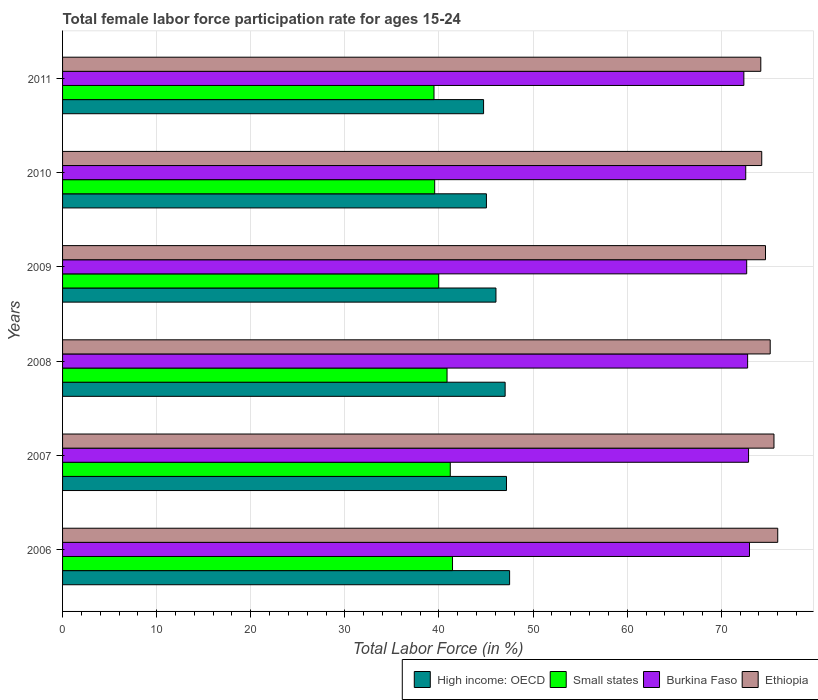How many different coloured bars are there?
Keep it short and to the point. 4. How many groups of bars are there?
Provide a succinct answer. 6. Are the number of bars per tick equal to the number of legend labels?
Make the answer very short. Yes. Are the number of bars on each tick of the Y-axis equal?
Provide a short and direct response. Yes. How many bars are there on the 3rd tick from the top?
Offer a very short reply. 4. What is the female labor force participation rate in Small states in 2009?
Your response must be concise. 39.97. Across all years, what is the maximum female labor force participation rate in Ethiopia?
Ensure brevity in your answer.  76. Across all years, what is the minimum female labor force participation rate in High income: OECD?
Offer a terse response. 44.74. In which year was the female labor force participation rate in Ethiopia maximum?
Make the answer very short. 2006. What is the total female labor force participation rate in Ethiopia in the graph?
Offer a terse response. 450. What is the difference between the female labor force participation rate in Burkina Faso in 2007 and that in 2010?
Keep it short and to the point. 0.3. What is the difference between the female labor force participation rate in High income: OECD in 2006 and the female labor force participation rate in Small states in 2008?
Give a very brief answer. 6.65. What is the average female labor force participation rate in Small states per year?
Keep it short and to the point. 40.41. In the year 2008, what is the difference between the female labor force participation rate in High income: OECD and female labor force participation rate in Small states?
Make the answer very short. 6.17. In how many years, is the female labor force participation rate in Burkina Faso greater than 18 %?
Provide a succinct answer. 6. What is the ratio of the female labor force participation rate in Small states in 2008 to that in 2011?
Your answer should be compact. 1.04. Is the female labor force participation rate in High income: OECD in 2007 less than that in 2010?
Keep it short and to the point. No. What is the difference between the highest and the second highest female labor force participation rate in High income: OECD?
Make the answer very short. 0.33. What is the difference between the highest and the lowest female labor force participation rate in Burkina Faso?
Give a very brief answer. 0.6. In how many years, is the female labor force participation rate in Small states greater than the average female labor force participation rate in Small states taken over all years?
Provide a short and direct response. 3. What does the 1st bar from the top in 2008 represents?
Give a very brief answer. Ethiopia. What does the 2nd bar from the bottom in 2007 represents?
Give a very brief answer. Small states. How many years are there in the graph?
Offer a terse response. 6. What is the difference between two consecutive major ticks on the X-axis?
Your answer should be very brief. 10. Are the values on the major ticks of X-axis written in scientific E-notation?
Your answer should be very brief. No. Does the graph contain any zero values?
Offer a very short reply. No. Does the graph contain grids?
Provide a short and direct response. Yes. Where does the legend appear in the graph?
Offer a very short reply. Bottom right. How many legend labels are there?
Your answer should be compact. 4. How are the legend labels stacked?
Provide a succinct answer. Horizontal. What is the title of the graph?
Your response must be concise. Total female labor force participation rate for ages 15-24. Does "Comoros" appear as one of the legend labels in the graph?
Your answer should be compact. No. What is the label or title of the X-axis?
Offer a terse response. Total Labor Force (in %). What is the Total Labor Force (in %) in High income: OECD in 2006?
Provide a succinct answer. 47.51. What is the Total Labor Force (in %) of Small states in 2006?
Your answer should be compact. 41.44. What is the Total Labor Force (in %) in Burkina Faso in 2006?
Keep it short and to the point. 73. What is the Total Labor Force (in %) in High income: OECD in 2007?
Make the answer very short. 47.17. What is the Total Labor Force (in %) in Small states in 2007?
Keep it short and to the point. 41.2. What is the Total Labor Force (in %) of Burkina Faso in 2007?
Ensure brevity in your answer.  72.9. What is the Total Labor Force (in %) in Ethiopia in 2007?
Your response must be concise. 75.6. What is the Total Labor Force (in %) of High income: OECD in 2008?
Ensure brevity in your answer.  47.03. What is the Total Labor Force (in %) of Small states in 2008?
Offer a very short reply. 40.86. What is the Total Labor Force (in %) of Burkina Faso in 2008?
Ensure brevity in your answer.  72.8. What is the Total Labor Force (in %) in Ethiopia in 2008?
Provide a short and direct response. 75.2. What is the Total Labor Force (in %) in High income: OECD in 2009?
Your answer should be compact. 46.06. What is the Total Labor Force (in %) of Small states in 2009?
Your response must be concise. 39.97. What is the Total Labor Force (in %) of Burkina Faso in 2009?
Offer a terse response. 72.7. What is the Total Labor Force (in %) of Ethiopia in 2009?
Keep it short and to the point. 74.7. What is the Total Labor Force (in %) in High income: OECD in 2010?
Provide a succinct answer. 45.04. What is the Total Labor Force (in %) of Small states in 2010?
Offer a terse response. 39.54. What is the Total Labor Force (in %) of Burkina Faso in 2010?
Offer a terse response. 72.6. What is the Total Labor Force (in %) of Ethiopia in 2010?
Ensure brevity in your answer.  74.3. What is the Total Labor Force (in %) in High income: OECD in 2011?
Your answer should be compact. 44.74. What is the Total Labor Force (in %) of Small states in 2011?
Ensure brevity in your answer.  39.47. What is the Total Labor Force (in %) in Burkina Faso in 2011?
Your answer should be very brief. 72.4. What is the Total Labor Force (in %) of Ethiopia in 2011?
Make the answer very short. 74.2. Across all years, what is the maximum Total Labor Force (in %) in High income: OECD?
Provide a short and direct response. 47.51. Across all years, what is the maximum Total Labor Force (in %) of Small states?
Your response must be concise. 41.44. Across all years, what is the minimum Total Labor Force (in %) in High income: OECD?
Keep it short and to the point. 44.74. Across all years, what is the minimum Total Labor Force (in %) in Small states?
Your answer should be very brief. 39.47. Across all years, what is the minimum Total Labor Force (in %) of Burkina Faso?
Make the answer very short. 72.4. Across all years, what is the minimum Total Labor Force (in %) of Ethiopia?
Ensure brevity in your answer.  74.2. What is the total Total Labor Force (in %) of High income: OECD in the graph?
Give a very brief answer. 277.55. What is the total Total Labor Force (in %) of Small states in the graph?
Provide a short and direct response. 242.49. What is the total Total Labor Force (in %) of Burkina Faso in the graph?
Provide a succinct answer. 436.4. What is the total Total Labor Force (in %) of Ethiopia in the graph?
Make the answer very short. 450. What is the difference between the Total Labor Force (in %) of High income: OECD in 2006 and that in 2007?
Provide a succinct answer. 0.33. What is the difference between the Total Labor Force (in %) of Small states in 2006 and that in 2007?
Your response must be concise. 0.24. What is the difference between the Total Labor Force (in %) in Burkina Faso in 2006 and that in 2007?
Offer a very short reply. 0.1. What is the difference between the Total Labor Force (in %) of High income: OECD in 2006 and that in 2008?
Your response must be concise. 0.47. What is the difference between the Total Labor Force (in %) of Small states in 2006 and that in 2008?
Your answer should be compact. 0.58. What is the difference between the Total Labor Force (in %) of High income: OECD in 2006 and that in 2009?
Give a very brief answer. 1.45. What is the difference between the Total Labor Force (in %) in Small states in 2006 and that in 2009?
Keep it short and to the point. 1.47. What is the difference between the Total Labor Force (in %) of Burkina Faso in 2006 and that in 2009?
Ensure brevity in your answer.  0.3. What is the difference between the Total Labor Force (in %) of Ethiopia in 2006 and that in 2009?
Offer a very short reply. 1.3. What is the difference between the Total Labor Force (in %) in High income: OECD in 2006 and that in 2010?
Your response must be concise. 2.46. What is the difference between the Total Labor Force (in %) in Small states in 2006 and that in 2010?
Offer a very short reply. 1.9. What is the difference between the Total Labor Force (in %) in Ethiopia in 2006 and that in 2010?
Your response must be concise. 1.7. What is the difference between the Total Labor Force (in %) in High income: OECD in 2006 and that in 2011?
Provide a succinct answer. 2.77. What is the difference between the Total Labor Force (in %) of Small states in 2006 and that in 2011?
Provide a succinct answer. 1.97. What is the difference between the Total Labor Force (in %) in High income: OECD in 2007 and that in 2008?
Provide a short and direct response. 0.14. What is the difference between the Total Labor Force (in %) of Small states in 2007 and that in 2008?
Provide a short and direct response. 0.34. What is the difference between the Total Labor Force (in %) in Burkina Faso in 2007 and that in 2008?
Provide a short and direct response. 0.1. What is the difference between the Total Labor Force (in %) of Ethiopia in 2007 and that in 2008?
Your response must be concise. 0.4. What is the difference between the Total Labor Force (in %) in High income: OECD in 2007 and that in 2009?
Offer a terse response. 1.12. What is the difference between the Total Labor Force (in %) in Small states in 2007 and that in 2009?
Make the answer very short. 1.23. What is the difference between the Total Labor Force (in %) in Ethiopia in 2007 and that in 2009?
Ensure brevity in your answer.  0.9. What is the difference between the Total Labor Force (in %) in High income: OECD in 2007 and that in 2010?
Your response must be concise. 2.13. What is the difference between the Total Labor Force (in %) of Small states in 2007 and that in 2010?
Your answer should be very brief. 1.66. What is the difference between the Total Labor Force (in %) in Ethiopia in 2007 and that in 2010?
Your answer should be very brief. 1.3. What is the difference between the Total Labor Force (in %) of High income: OECD in 2007 and that in 2011?
Give a very brief answer. 2.43. What is the difference between the Total Labor Force (in %) in Small states in 2007 and that in 2011?
Your answer should be very brief. 1.73. What is the difference between the Total Labor Force (in %) in Burkina Faso in 2007 and that in 2011?
Provide a short and direct response. 0.5. What is the difference between the Total Labor Force (in %) in High income: OECD in 2008 and that in 2009?
Offer a very short reply. 0.98. What is the difference between the Total Labor Force (in %) in Small states in 2008 and that in 2009?
Your answer should be very brief. 0.88. What is the difference between the Total Labor Force (in %) of Burkina Faso in 2008 and that in 2009?
Your answer should be very brief. 0.1. What is the difference between the Total Labor Force (in %) of Ethiopia in 2008 and that in 2009?
Provide a succinct answer. 0.5. What is the difference between the Total Labor Force (in %) of High income: OECD in 2008 and that in 2010?
Your answer should be very brief. 1.99. What is the difference between the Total Labor Force (in %) of Small states in 2008 and that in 2010?
Keep it short and to the point. 1.31. What is the difference between the Total Labor Force (in %) in High income: OECD in 2008 and that in 2011?
Make the answer very short. 2.29. What is the difference between the Total Labor Force (in %) in Small states in 2008 and that in 2011?
Ensure brevity in your answer.  1.39. What is the difference between the Total Labor Force (in %) of High income: OECD in 2009 and that in 2010?
Provide a succinct answer. 1.01. What is the difference between the Total Labor Force (in %) of Small states in 2009 and that in 2010?
Your response must be concise. 0.43. What is the difference between the Total Labor Force (in %) of High income: OECD in 2009 and that in 2011?
Offer a very short reply. 1.32. What is the difference between the Total Labor Force (in %) of Small states in 2009 and that in 2011?
Your answer should be compact. 0.5. What is the difference between the Total Labor Force (in %) in High income: OECD in 2010 and that in 2011?
Provide a short and direct response. 0.3. What is the difference between the Total Labor Force (in %) of Small states in 2010 and that in 2011?
Keep it short and to the point. 0.07. What is the difference between the Total Labor Force (in %) of High income: OECD in 2006 and the Total Labor Force (in %) of Small states in 2007?
Offer a terse response. 6.31. What is the difference between the Total Labor Force (in %) in High income: OECD in 2006 and the Total Labor Force (in %) in Burkina Faso in 2007?
Your answer should be compact. -25.39. What is the difference between the Total Labor Force (in %) in High income: OECD in 2006 and the Total Labor Force (in %) in Ethiopia in 2007?
Provide a succinct answer. -28.09. What is the difference between the Total Labor Force (in %) of Small states in 2006 and the Total Labor Force (in %) of Burkina Faso in 2007?
Your answer should be very brief. -31.46. What is the difference between the Total Labor Force (in %) of Small states in 2006 and the Total Labor Force (in %) of Ethiopia in 2007?
Give a very brief answer. -34.16. What is the difference between the Total Labor Force (in %) in Burkina Faso in 2006 and the Total Labor Force (in %) in Ethiopia in 2007?
Keep it short and to the point. -2.6. What is the difference between the Total Labor Force (in %) in High income: OECD in 2006 and the Total Labor Force (in %) in Small states in 2008?
Provide a succinct answer. 6.65. What is the difference between the Total Labor Force (in %) of High income: OECD in 2006 and the Total Labor Force (in %) of Burkina Faso in 2008?
Offer a terse response. -25.29. What is the difference between the Total Labor Force (in %) of High income: OECD in 2006 and the Total Labor Force (in %) of Ethiopia in 2008?
Keep it short and to the point. -27.69. What is the difference between the Total Labor Force (in %) in Small states in 2006 and the Total Labor Force (in %) in Burkina Faso in 2008?
Your answer should be very brief. -31.36. What is the difference between the Total Labor Force (in %) in Small states in 2006 and the Total Labor Force (in %) in Ethiopia in 2008?
Your answer should be compact. -33.76. What is the difference between the Total Labor Force (in %) in High income: OECD in 2006 and the Total Labor Force (in %) in Small states in 2009?
Provide a succinct answer. 7.53. What is the difference between the Total Labor Force (in %) of High income: OECD in 2006 and the Total Labor Force (in %) of Burkina Faso in 2009?
Provide a short and direct response. -25.19. What is the difference between the Total Labor Force (in %) of High income: OECD in 2006 and the Total Labor Force (in %) of Ethiopia in 2009?
Make the answer very short. -27.19. What is the difference between the Total Labor Force (in %) in Small states in 2006 and the Total Labor Force (in %) in Burkina Faso in 2009?
Provide a short and direct response. -31.26. What is the difference between the Total Labor Force (in %) of Small states in 2006 and the Total Labor Force (in %) of Ethiopia in 2009?
Offer a very short reply. -33.26. What is the difference between the Total Labor Force (in %) in Burkina Faso in 2006 and the Total Labor Force (in %) in Ethiopia in 2009?
Provide a short and direct response. -1.7. What is the difference between the Total Labor Force (in %) in High income: OECD in 2006 and the Total Labor Force (in %) in Small states in 2010?
Your answer should be very brief. 7.96. What is the difference between the Total Labor Force (in %) in High income: OECD in 2006 and the Total Labor Force (in %) in Burkina Faso in 2010?
Your answer should be compact. -25.09. What is the difference between the Total Labor Force (in %) in High income: OECD in 2006 and the Total Labor Force (in %) in Ethiopia in 2010?
Provide a short and direct response. -26.79. What is the difference between the Total Labor Force (in %) in Small states in 2006 and the Total Labor Force (in %) in Burkina Faso in 2010?
Offer a very short reply. -31.16. What is the difference between the Total Labor Force (in %) of Small states in 2006 and the Total Labor Force (in %) of Ethiopia in 2010?
Your answer should be compact. -32.86. What is the difference between the Total Labor Force (in %) in Burkina Faso in 2006 and the Total Labor Force (in %) in Ethiopia in 2010?
Your answer should be very brief. -1.3. What is the difference between the Total Labor Force (in %) in High income: OECD in 2006 and the Total Labor Force (in %) in Small states in 2011?
Offer a terse response. 8.03. What is the difference between the Total Labor Force (in %) in High income: OECD in 2006 and the Total Labor Force (in %) in Burkina Faso in 2011?
Offer a very short reply. -24.89. What is the difference between the Total Labor Force (in %) in High income: OECD in 2006 and the Total Labor Force (in %) in Ethiopia in 2011?
Make the answer very short. -26.69. What is the difference between the Total Labor Force (in %) of Small states in 2006 and the Total Labor Force (in %) of Burkina Faso in 2011?
Your answer should be compact. -30.96. What is the difference between the Total Labor Force (in %) in Small states in 2006 and the Total Labor Force (in %) in Ethiopia in 2011?
Your response must be concise. -32.76. What is the difference between the Total Labor Force (in %) of High income: OECD in 2007 and the Total Labor Force (in %) of Small states in 2008?
Make the answer very short. 6.32. What is the difference between the Total Labor Force (in %) of High income: OECD in 2007 and the Total Labor Force (in %) of Burkina Faso in 2008?
Provide a succinct answer. -25.63. What is the difference between the Total Labor Force (in %) of High income: OECD in 2007 and the Total Labor Force (in %) of Ethiopia in 2008?
Your answer should be very brief. -28.03. What is the difference between the Total Labor Force (in %) in Small states in 2007 and the Total Labor Force (in %) in Burkina Faso in 2008?
Provide a succinct answer. -31.6. What is the difference between the Total Labor Force (in %) in Small states in 2007 and the Total Labor Force (in %) in Ethiopia in 2008?
Ensure brevity in your answer.  -34. What is the difference between the Total Labor Force (in %) in Burkina Faso in 2007 and the Total Labor Force (in %) in Ethiopia in 2008?
Keep it short and to the point. -2.3. What is the difference between the Total Labor Force (in %) of High income: OECD in 2007 and the Total Labor Force (in %) of Small states in 2009?
Your answer should be very brief. 7.2. What is the difference between the Total Labor Force (in %) of High income: OECD in 2007 and the Total Labor Force (in %) of Burkina Faso in 2009?
Make the answer very short. -25.53. What is the difference between the Total Labor Force (in %) in High income: OECD in 2007 and the Total Labor Force (in %) in Ethiopia in 2009?
Make the answer very short. -27.53. What is the difference between the Total Labor Force (in %) of Small states in 2007 and the Total Labor Force (in %) of Burkina Faso in 2009?
Offer a terse response. -31.5. What is the difference between the Total Labor Force (in %) in Small states in 2007 and the Total Labor Force (in %) in Ethiopia in 2009?
Provide a short and direct response. -33.5. What is the difference between the Total Labor Force (in %) in Burkina Faso in 2007 and the Total Labor Force (in %) in Ethiopia in 2009?
Ensure brevity in your answer.  -1.8. What is the difference between the Total Labor Force (in %) of High income: OECD in 2007 and the Total Labor Force (in %) of Small states in 2010?
Make the answer very short. 7.63. What is the difference between the Total Labor Force (in %) of High income: OECD in 2007 and the Total Labor Force (in %) of Burkina Faso in 2010?
Your answer should be very brief. -25.43. What is the difference between the Total Labor Force (in %) in High income: OECD in 2007 and the Total Labor Force (in %) in Ethiopia in 2010?
Offer a terse response. -27.13. What is the difference between the Total Labor Force (in %) of Small states in 2007 and the Total Labor Force (in %) of Burkina Faso in 2010?
Ensure brevity in your answer.  -31.4. What is the difference between the Total Labor Force (in %) of Small states in 2007 and the Total Labor Force (in %) of Ethiopia in 2010?
Make the answer very short. -33.1. What is the difference between the Total Labor Force (in %) in High income: OECD in 2007 and the Total Labor Force (in %) in Small states in 2011?
Offer a terse response. 7.7. What is the difference between the Total Labor Force (in %) of High income: OECD in 2007 and the Total Labor Force (in %) of Burkina Faso in 2011?
Provide a succinct answer. -25.23. What is the difference between the Total Labor Force (in %) of High income: OECD in 2007 and the Total Labor Force (in %) of Ethiopia in 2011?
Your answer should be compact. -27.03. What is the difference between the Total Labor Force (in %) of Small states in 2007 and the Total Labor Force (in %) of Burkina Faso in 2011?
Ensure brevity in your answer.  -31.2. What is the difference between the Total Labor Force (in %) in Small states in 2007 and the Total Labor Force (in %) in Ethiopia in 2011?
Provide a short and direct response. -33. What is the difference between the Total Labor Force (in %) in Burkina Faso in 2007 and the Total Labor Force (in %) in Ethiopia in 2011?
Make the answer very short. -1.3. What is the difference between the Total Labor Force (in %) in High income: OECD in 2008 and the Total Labor Force (in %) in Small states in 2009?
Your response must be concise. 7.06. What is the difference between the Total Labor Force (in %) of High income: OECD in 2008 and the Total Labor Force (in %) of Burkina Faso in 2009?
Give a very brief answer. -25.67. What is the difference between the Total Labor Force (in %) in High income: OECD in 2008 and the Total Labor Force (in %) in Ethiopia in 2009?
Offer a terse response. -27.67. What is the difference between the Total Labor Force (in %) of Small states in 2008 and the Total Labor Force (in %) of Burkina Faso in 2009?
Your response must be concise. -31.84. What is the difference between the Total Labor Force (in %) of Small states in 2008 and the Total Labor Force (in %) of Ethiopia in 2009?
Your answer should be very brief. -33.84. What is the difference between the Total Labor Force (in %) of High income: OECD in 2008 and the Total Labor Force (in %) of Small states in 2010?
Keep it short and to the point. 7.49. What is the difference between the Total Labor Force (in %) of High income: OECD in 2008 and the Total Labor Force (in %) of Burkina Faso in 2010?
Give a very brief answer. -25.57. What is the difference between the Total Labor Force (in %) of High income: OECD in 2008 and the Total Labor Force (in %) of Ethiopia in 2010?
Offer a very short reply. -27.27. What is the difference between the Total Labor Force (in %) in Small states in 2008 and the Total Labor Force (in %) in Burkina Faso in 2010?
Provide a succinct answer. -31.74. What is the difference between the Total Labor Force (in %) in Small states in 2008 and the Total Labor Force (in %) in Ethiopia in 2010?
Your answer should be very brief. -33.44. What is the difference between the Total Labor Force (in %) in High income: OECD in 2008 and the Total Labor Force (in %) in Small states in 2011?
Your response must be concise. 7.56. What is the difference between the Total Labor Force (in %) in High income: OECD in 2008 and the Total Labor Force (in %) in Burkina Faso in 2011?
Keep it short and to the point. -25.37. What is the difference between the Total Labor Force (in %) in High income: OECD in 2008 and the Total Labor Force (in %) in Ethiopia in 2011?
Your answer should be very brief. -27.17. What is the difference between the Total Labor Force (in %) of Small states in 2008 and the Total Labor Force (in %) of Burkina Faso in 2011?
Provide a short and direct response. -31.54. What is the difference between the Total Labor Force (in %) in Small states in 2008 and the Total Labor Force (in %) in Ethiopia in 2011?
Provide a succinct answer. -33.34. What is the difference between the Total Labor Force (in %) of High income: OECD in 2009 and the Total Labor Force (in %) of Small states in 2010?
Provide a succinct answer. 6.51. What is the difference between the Total Labor Force (in %) in High income: OECD in 2009 and the Total Labor Force (in %) in Burkina Faso in 2010?
Provide a succinct answer. -26.54. What is the difference between the Total Labor Force (in %) in High income: OECD in 2009 and the Total Labor Force (in %) in Ethiopia in 2010?
Provide a short and direct response. -28.24. What is the difference between the Total Labor Force (in %) of Small states in 2009 and the Total Labor Force (in %) of Burkina Faso in 2010?
Offer a terse response. -32.63. What is the difference between the Total Labor Force (in %) of Small states in 2009 and the Total Labor Force (in %) of Ethiopia in 2010?
Your answer should be compact. -34.33. What is the difference between the Total Labor Force (in %) of High income: OECD in 2009 and the Total Labor Force (in %) of Small states in 2011?
Your response must be concise. 6.58. What is the difference between the Total Labor Force (in %) in High income: OECD in 2009 and the Total Labor Force (in %) in Burkina Faso in 2011?
Offer a very short reply. -26.34. What is the difference between the Total Labor Force (in %) in High income: OECD in 2009 and the Total Labor Force (in %) in Ethiopia in 2011?
Your answer should be very brief. -28.14. What is the difference between the Total Labor Force (in %) in Small states in 2009 and the Total Labor Force (in %) in Burkina Faso in 2011?
Your answer should be very brief. -32.43. What is the difference between the Total Labor Force (in %) of Small states in 2009 and the Total Labor Force (in %) of Ethiopia in 2011?
Ensure brevity in your answer.  -34.23. What is the difference between the Total Labor Force (in %) of Burkina Faso in 2009 and the Total Labor Force (in %) of Ethiopia in 2011?
Offer a very short reply. -1.5. What is the difference between the Total Labor Force (in %) of High income: OECD in 2010 and the Total Labor Force (in %) of Small states in 2011?
Your answer should be very brief. 5.57. What is the difference between the Total Labor Force (in %) of High income: OECD in 2010 and the Total Labor Force (in %) of Burkina Faso in 2011?
Provide a succinct answer. -27.36. What is the difference between the Total Labor Force (in %) of High income: OECD in 2010 and the Total Labor Force (in %) of Ethiopia in 2011?
Keep it short and to the point. -29.16. What is the difference between the Total Labor Force (in %) of Small states in 2010 and the Total Labor Force (in %) of Burkina Faso in 2011?
Provide a short and direct response. -32.86. What is the difference between the Total Labor Force (in %) in Small states in 2010 and the Total Labor Force (in %) in Ethiopia in 2011?
Give a very brief answer. -34.66. What is the difference between the Total Labor Force (in %) in Burkina Faso in 2010 and the Total Labor Force (in %) in Ethiopia in 2011?
Offer a terse response. -1.6. What is the average Total Labor Force (in %) in High income: OECD per year?
Give a very brief answer. 46.26. What is the average Total Labor Force (in %) of Small states per year?
Keep it short and to the point. 40.41. What is the average Total Labor Force (in %) of Burkina Faso per year?
Your response must be concise. 72.73. In the year 2006, what is the difference between the Total Labor Force (in %) of High income: OECD and Total Labor Force (in %) of Small states?
Make the answer very short. 6.07. In the year 2006, what is the difference between the Total Labor Force (in %) in High income: OECD and Total Labor Force (in %) in Burkina Faso?
Give a very brief answer. -25.49. In the year 2006, what is the difference between the Total Labor Force (in %) of High income: OECD and Total Labor Force (in %) of Ethiopia?
Offer a very short reply. -28.49. In the year 2006, what is the difference between the Total Labor Force (in %) of Small states and Total Labor Force (in %) of Burkina Faso?
Make the answer very short. -31.56. In the year 2006, what is the difference between the Total Labor Force (in %) of Small states and Total Labor Force (in %) of Ethiopia?
Provide a succinct answer. -34.56. In the year 2006, what is the difference between the Total Labor Force (in %) in Burkina Faso and Total Labor Force (in %) in Ethiopia?
Provide a short and direct response. -3. In the year 2007, what is the difference between the Total Labor Force (in %) of High income: OECD and Total Labor Force (in %) of Small states?
Give a very brief answer. 5.97. In the year 2007, what is the difference between the Total Labor Force (in %) in High income: OECD and Total Labor Force (in %) in Burkina Faso?
Give a very brief answer. -25.73. In the year 2007, what is the difference between the Total Labor Force (in %) of High income: OECD and Total Labor Force (in %) of Ethiopia?
Ensure brevity in your answer.  -28.43. In the year 2007, what is the difference between the Total Labor Force (in %) in Small states and Total Labor Force (in %) in Burkina Faso?
Your answer should be very brief. -31.7. In the year 2007, what is the difference between the Total Labor Force (in %) of Small states and Total Labor Force (in %) of Ethiopia?
Ensure brevity in your answer.  -34.4. In the year 2008, what is the difference between the Total Labor Force (in %) in High income: OECD and Total Labor Force (in %) in Small states?
Give a very brief answer. 6.17. In the year 2008, what is the difference between the Total Labor Force (in %) of High income: OECD and Total Labor Force (in %) of Burkina Faso?
Keep it short and to the point. -25.77. In the year 2008, what is the difference between the Total Labor Force (in %) of High income: OECD and Total Labor Force (in %) of Ethiopia?
Give a very brief answer. -28.17. In the year 2008, what is the difference between the Total Labor Force (in %) in Small states and Total Labor Force (in %) in Burkina Faso?
Keep it short and to the point. -31.94. In the year 2008, what is the difference between the Total Labor Force (in %) in Small states and Total Labor Force (in %) in Ethiopia?
Provide a short and direct response. -34.34. In the year 2009, what is the difference between the Total Labor Force (in %) in High income: OECD and Total Labor Force (in %) in Small states?
Make the answer very short. 6.08. In the year 2009, what is the difference between the Total Labor Force (in %) of High income: OECD and Total Labor Force (in %) of Burkina Faso?
Keep it short and to the point. -26.64. In the year 2009, what is the difference between the Total Labor Force (in %) of High income: OECD and Total Labor Force (in %) of Ethiopia?
Give a very brief answer. -28.64. In the year 2009, what is the difference between the Total Labor Force (in %) in Small states and Total Labor Force (in %) in Burkina Faso?
Give a very brief answer. -32.73. In the year 2009, what is the difference between the Total Labor Force (in %) of Small states and Total Labor Force (in %) of Ethiopia?
Provide a short and direct response. -34.73. In the year 2009, what is the difference between the Total Labor Force (in %) in Burkina Faso and Total Labor Force (in %) in Ethiopia?
Keep it short and to the point. -2. In the year 2010, what is the difference between the Total Labor Force (in %) in High income: OECD and Total Labor Force (in %) in Small states?
Give a very brief answer. 5.5. In the year 2010, what is the difference between the Total Labor Force (in %) of High income: OECD and Total Labor Force (in %) of Burkina Faso?
Your answer should be very brief. -27.56. In the year 2010, what is the difference between the Total Labor Force (in %) in High income: OECD and Total Labor Force (in %) in Ethiopia?
Offer a terse response. -29.26. In the year 2010, what is the difference between the Total Labor Force (in %) of Small states and Total Labor Force (in %) of Burkina Faso?
Your response must be concise. -33.06. In the year 2010, what is the difference between the Total Labor Force (in %) of Small states and Total Labor Force (in %) of Ethiopia?
Ensure brevity in your answer.  -34.76. In the year 2011, what is the difference between the Total Labor Force (in %) of High income: OECD and Total Labor Force (in %) of Small states?
Offer a terse response. 5.27. In the year 2011, what is the difference between the Total Labor Force (in %) in High income: OECD and Total Labor Force (in %) in Burkina Faso?
Your answer should be very brief. -27.66. In the year 2011, what is the difference between the Total Labor Force (in %) of High income: OECD and Total Labor Force (in %) of Ethiopia?
Keep it short and to the point. -29.46. In the year 2011, what is the difference between the Total Labor Force (in %) in Small states and Total Labor Force (in %) in Burkina Faso?
Offer a very short reply. -32.93. In the year 2011, what is the difference between the Total Labor Force (in %) of Small states and Total Labor Force (in %) of Ethiopia?
Give a very brief answer. -34.73. In the year 2011, what is the difference between the Total Labor Force (in %) of Burkina Faso and Total Labor Force (in %) of Ethiopia?
Keep it short and to the point. -1.8. What is the ratio of the Total Labor Force (in %) in Small states in 2006 to that in 2007?
Give a very brief answer. 1.01. What is the ratio of the Total Labor Force (in %) in Burkina Faso in 2006 to that in 2007?
Offer a terse response. 1. What is the ratio of the Total Labor Force (in %) of Small states in 2006 to that in 2008?
Your response must be concise. 1.01. What is the ratio of the Total Labor Force (in %) of Ethiopia in 2006 to that in 2008?
Offer a terse response. 1.01. What is the ratio of the Total Labor Force (in %) in High income: OECD in 2006 to that in 2009?
Provide a succinct answer. 1.03. What is the ratio of the Total Labor Force (in %) in Small states in 2006 to that in 2009?
Provide a short and direct response. 1.04. What is the ratio of the Total Labor Force (in %) in Ethiopia in 2006 to that in 2009?
Provide a short and direct response. 1.02. What is the ratio of the Total Labor Force (in %) of High income: OECD in 2006 to that in 2010?
Offer a terse response. 1.05. What is the ratio of the Total Labor Force (in %) in Small states in 2006 to that in 2010?
Your response must be concise. 1.05. What is the ratio of the Total Labor Force (in %) of Burkina Faso in 2006 to that in 2010?
Your answer should be very brief. 1.01. What is the ratio of the Total Labor Force (in %) of Ethiopia in 2006 to that in 2010?
Keep it short and to the point. 1.02. What is the ratio of the Total Labor Force (in %) in High income: OECD in 2006 to that in 2011?
Provide a short and direct response. 1.06. What is the ratio of the Total Labor Force (in %) in Small states in 2006 to that in 2011?
Make the answer very short. 1.05. What is the ratio of the Total Labor Force (in %) of Burkina Faso in 2006 to that in 2011?
Your answer should be very brief. 1.01. What is the ratio of the Total Labor Force (in %) of Ethiopia in 2006 to that in 2011?
Offer a very short reply. 1.02. What is the ratio of the Total Labor Force (in %) of Small states in 2007 to that in 2008?
Your answer should be compact. 1.01. What is the ratio of the Total Labor Force (in %) in Burkina Faso in 2007 to that in 2008?
Offer a very short reply. 1. What is the ratio of the Total Labor Force (in %) in Ethiopia in 2007 to that in 2008?
Offer a terse response. 1.01. What is the ratio of the Total Labor Force (in %) in High income: OECD in 2007 to that in 2009?
Offer a terse response. 1.02. What is the ratio of the Total Labor Force (in %) in Small states in 2007 to that in 2009?
Your response must be concise. 1.03. What is the ratio of the Total Labor Force (in %) in Burkina Faso in 2007 to that in 2009?
Provide a short and direct response. 1. What is the ratio of the Total Labor Force (in %) in Ethiopia in 2007 to that in 2009?
Your answer should be very brief. 1.01. What is the ratio of the Total Labor Force (in %) of High income: OECD in 2007 to that in 2010?
Keep it short and to the point. 1.05. What is the ratio of the Total Labor Force (in %) in Small states in 2007 to that in 2010?
Keep it short and to the point. 1.04. What is the ratio of the Total Labor Force (in %) in Burkina Faso in 2007 to that in 2010?
Ensure brevity in your answer.  1. What is the ratio of the Total Labor Force (in %) in Ethiopia in 2007 to that in 2010?
Provide a succinct answer. 1.02. What is the ratio of the Total Labor Force (in %) in High income: OECD in 2007 to that in 2011?
Offer a very short reply. 1.05. What is the ratio of the Total Labor Force (in %) of Small states in 2007 to that in 2011?
Provide a succinct answer. 1.04. What is the ratio of the Total Labor Force (in %) in Burkina Faso in 2007 to that in 2011?
Your response must be concise. 1.01. What is the ratio of the Total Labor Force (in %) in Ethiopia in 2007 to that in 2011?
Keep it short and to the point. 1.02. What is the ratio of the Total Labor Force (in %) of High income: OECD in 2008 to that in 2009?
Make the answer very short. 1.02. What is the ratio of the Total Labor Force (in %) in Small states in 2008 to that in 2009?
Provide a short and direct response. 1.02. What is the ratio of the Total Labor Force (in %) of Burkina Faso in 2008 to that in 2009?
Offer a very short reply. 1. What is the ratio of the Total Labor Force (in %) of Ethiopia in 2008 to that in 2009?
Provide a short and direct response. 1.01. What is the ratio of the Total Labor Force (in %) in High income: OECD in 2008 to that in 2010?
Your answer should be compact. 1.04. What is the ratio of the Total Labor Force (in %) in Small states in 2008 to that in 2010?
Your answer should be compact. 1.03. What is the ratio of the Total Labor Force (in %) in Burkina Faso in 2008 to that in 2010?
Give a very brief answer. 1. What is the ratio of the Total Labor Force (in %) of Ethiopia in 2008 to that in 2010?
Offer a terse response. 1.01. What is the ratio of the Total Labor Force (in %) in High income: OECD in 2008 to that in 2011?
Provide a succinct answer. 1.05. What is the ratio of the Total Labor Force (in %) of Small states in 2008 to that in 2011?
Your answer should be very brief. 1.04. What is the ratio of the Total Labor Force (in %) in Burkina Faso in 2008 to that in 2011?
Ensure brevity in your answer.  1.01. What is the ratio of the Total Labor Force (in %) of Ethiopia in 2008 to that in 2011?
Provide a short and direct response. 1.01. What is the ratio of the Total Labor Force (in %) of High income: OECD in 2009 to that in 2010?
Your response must be concise. 1.02. What is the ratio of the Total Labor Force (in %) in Small states in 2009 to that in 2010?
Provide a short and direct response. 1.01. What is the ratio of the Total Labor Force (in %) of Ethiopia in 2009 to that in 2010?
Your answer should be compact. 1.01. What is the ratio of the Total Labor Force (in %) of High income: OECD in 2009 to that in 2011?
Your response must be concise. 1.03. What is the ratio of the Total Labor Force (in %) of Small states in 2009 to that in 2011?
Offer a terse response. 1.01. What is the ratio of the Total Labor Force (in %) in Burkina Faso in 2009 to that in 2011?
Offer a terse response. 1. What is the ratio of the Total Labor Force (in %) of High income: OECD in 2010 to that in 2011?
Make the answer very short. 1.01. What is the ratio of the Total Labor Force (in %) in Small states in 2010 to that in 2011?
Ensure brevity in your answer.  1. What is the difference between the highest and the second highest Total Labor Force (in %) in High income: OECD?
Your answer should be compact. 0.33. What is the difference between the highest and the second highest Total Labor Force (in %) of Small states?
Offer a terse response. 0.24. What is the difference between the highest and the lowest Total Labor Force (in %) of High income: OECD?
Keep it short and to the point. 2.77. What is the difference between the highest and the lowest Total Labor Force (in %) of Small states?
Your answer should be compact. 1.97. What is the difference between the highest and the lowest Total Labor Force (in %) in Burkina Faso?
Make the answer very short. 0.6. 